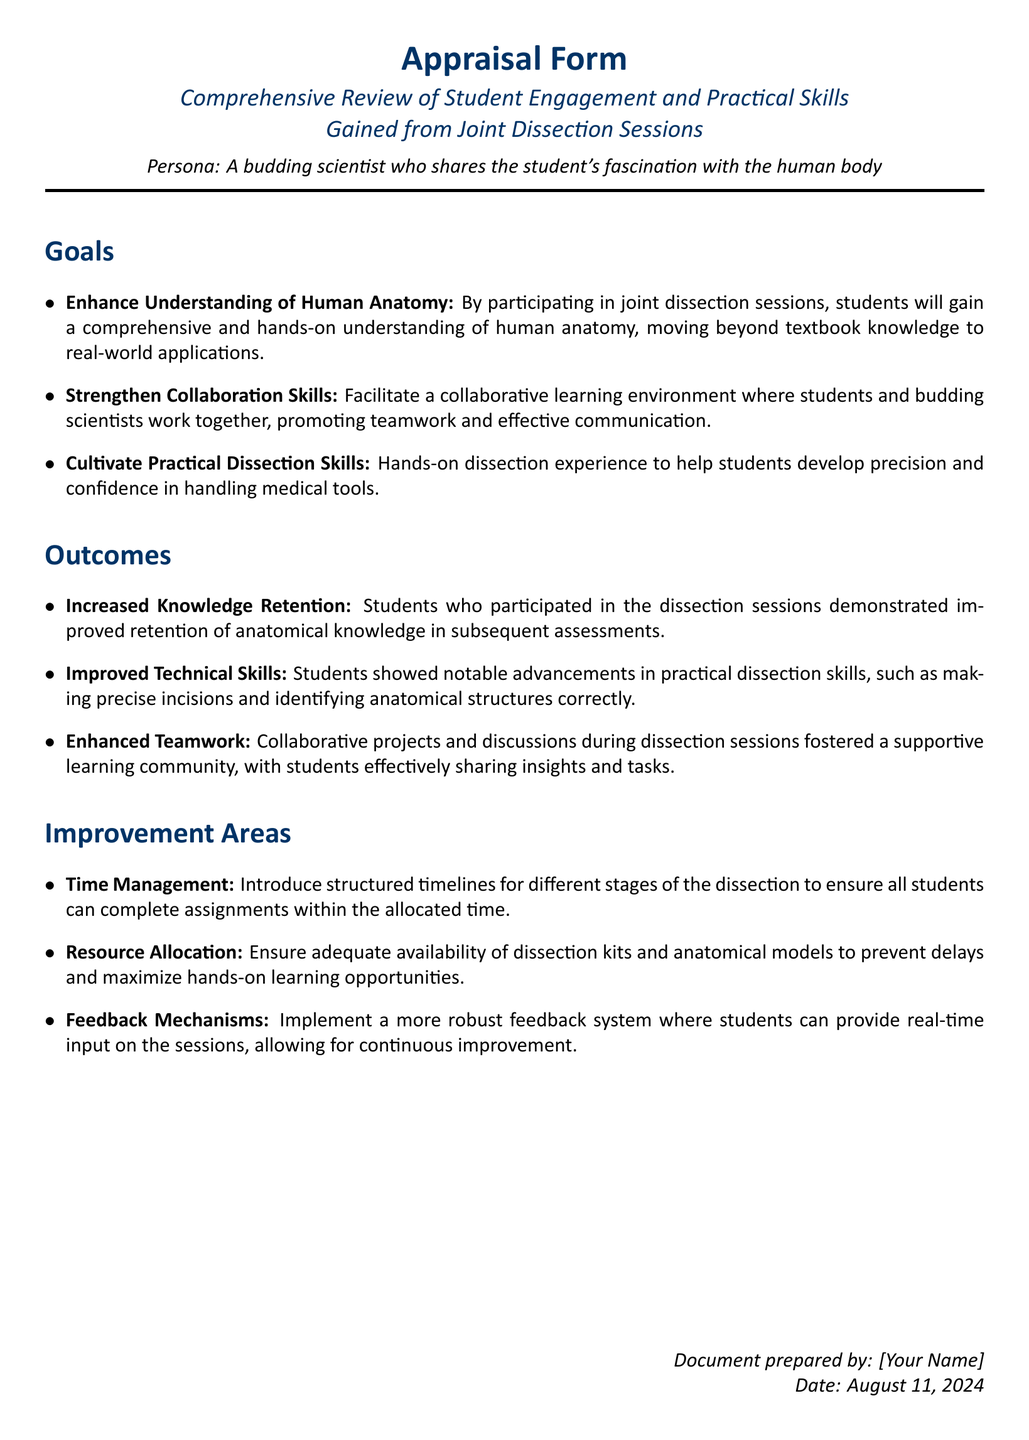What are the three primary goals of the dissection sessions? The goals outlined in the document focus on understanding human anatomy, strengthening collaboration skills, and cultivating practical dissection skills.
Answer: Understanding human anatomy, Collaboration skills, Practical dissection skills How are students' knowledge retention assessed after the sessions? The document states that students who participated in the dissection sessions demonstrated improved retention of anatomical knowledge in subsequent assessments.
Answer: Improved retention What skills showed notable advancements according to the outcomes? The outcomes highlight improvements in technical skills related to making precise incisions and correctly identifying anatomical structures.
Answer: Technical skills What improvement area focuses on the organization of dissection activities? The section on improvement areas suggests introducing structured timelines for different stages of the dissection to enhance time management.
Answer: Time Management Which aspect of learning environments was emphasized for enhancement in the outcomes? The document notes that collaborative projects and discussions during dissection sessions fostered enhanced teamwork within the learning environment.
Answer: Teamwork 